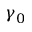Convert formula to latex. <formula><loc_0><loc_0><loc_500><loc_500>\gamma _ { 0 }</formula> 